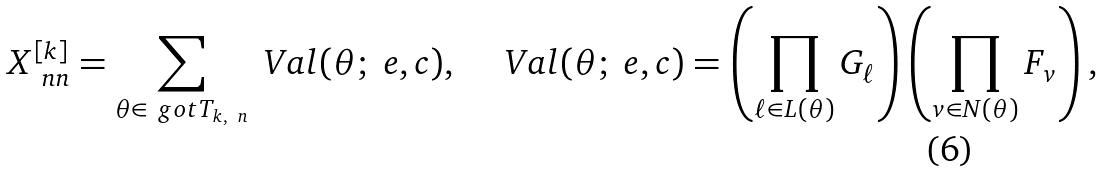Convert formula to latex. <formula><loc_0><loc_0><loc_500><loc_500>X _ { \ n n } ^ { [ k ] } = \sum _ { \theta \in \ g o t T _ { k , \ n } } \ V a l ( \theta ; \ e , c ) , \quad \ V a l ( \theta ; \ e , c ) = \left ( \prod _ { \ell \in L ( \theta ) } G _ { \ell } \right ) \left ( \prod _ { v \in N ( \theta ) } F _ { v } \right ) ,</formula> 